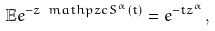<formula> <loc_0><loc_0><loc_500><loc_500>\mathbb { E } e ^ { - z \ m a t h p z c { S } ^ { \alpha } ( t ) } = e ^ { - t z ^ { \alpha } } ,</formula> 